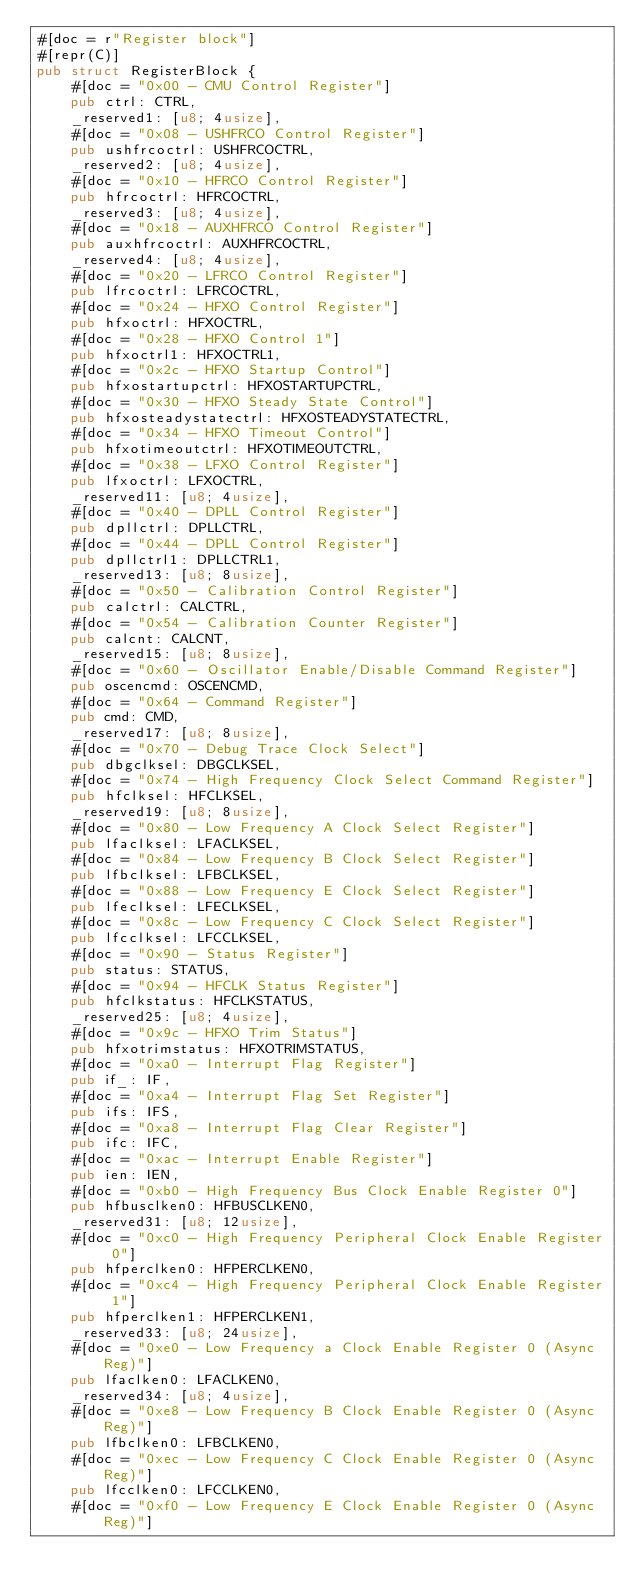<code> <loc_0><loc_0><loc_500><loc_500><_Rust_>#[doc = r"Register block"]
#[repr(C)]
pub struct RegisterBlock {
    #[doc = "0x00 - CMU Control Register"]
    pub ctrl: CTRL,
    _reserved1: [u8; 4usize],
    #[doc = "0x08 - USHFRCO Control Register"]
    pub ushfrcoctrl: USHFRCOCTRL,
    _reserved2: [u8; 4usize],
    #[doc = "0x10 - HFRCO Control Register"]
    pub hfrcoctrl: HFRCOCTRL,
    _reserved3: [u8; 4usize],
    #[doc = "0x18 - AUXHFRCO Control Register"]
    pub auxhfrcoctrl: AUXHFRCOCTRL,
    _reserved4: [u8; 4usize],
    #[doc = "0x20 - LFRCO Control Register"]
    pub lfrcoctrl: LFRCOCTRL,
    #[doc = "0x24 - HFXO Control Register"]
    pub hfxoctrl: HFXOCTRL,
    #[doc = "0x28 - HFXO Control 1"]
    pub hfxoctrl1: HFXOCTRL1,
    #[doc = "0x2c - HFXO Startup Control"]
    pub hfxostartupctrl: HFXOSTARTUPCTRL,
    #[doc = "0x30 - HFXO Steady State Control"]
    pub hfxosteadystatectrl: HFXOSTEADYSTATECTRL,
    #[doc = "0x34 - HFXO Timeout Control"]
    pub hfxotimeoutctrl: HFXOTIMEOUTCTRL,
    #[doc = "0x38 - LFXO Control Register"]
    pub lfxoctrl: LFXOCTRL,
    _reserved11: [u8; 4usize],
    #[doc = "0x40 - DPLL Control Register"]
    pub dpllctrl: DPLLCTRL,
    #[doc = "0x44 - DPLL Control Register"]
    pub dpllctrl1: DPLLCTRL1,
    _reserved13: [u8; 8usize],
    #[doc = "0x50 - Calibration Control Register"]
    pub calctrl: CALCTRL,
    #[doc = "0x54 - Calibration Counter Register"]
    pub calcnt: CALCNT,
    _reserved15: [u8; 8usize],
    #[doc = "0x60 - Oscillator Enable/Disable Command Register"]
    pub oscencmd: OSCENCMD,
    #[doc = "0x64 - Command Register"]
    pub cmd: CMD,
    _reserved17: [u8; 8usize],
    #[doc = "0x70 - Debug Trace Clock Select"]
    pub dbgclksel: DBGCLKSEL,
    #[doc = "0x74 - High Frequency Clock Select Command Register"]
    pub hfclksel: HFCLKSEL,
    _reserved19: [u8; 8usize],
    #[doc = "0x80 - Low Frequency A Clock Select Register"]
    pub lfaclksel: LFACLKSEL,
    #[doc = "0x84 - Low Frequency B Clock Select Register"]
    pub lfbclksel: LFBCLKSEL,
    #[doc = "0x88 - Low Frequency E Clock Select Register"]
    pub lfeclksel: LFECLKSEL,
    #[doc = "0x8c - Low Frequency C Clock Select Register"]
    pub lfcclksel: LFCCLKSEL,
    #[doc = "0x90 - Status Register"]
    pub status: STATUS,
    #[doc = "0x94 - HFCLK Status Register"]
    pub hfclkstatus: HFCLKSTATUS,
    _reserved25: [u8; 4usize],
    #[doc = "0x9c - HFXO Trim Status"]
    pub hfxotrimstatus: HFXOTRIMSTATUS,
    #[doc = "0xa0 - Interrupt Flag Register"]
    pub if_: IF,
    #[doc = "0xa4 - Interrupt Flag Set Register"]
    pub ifs: IFS,
    #[doc = "0xa8 - Interrupt Flag Clear Register"]
    pub ifc: IFC,
    #[doc = "0xac - Interrupt Enable Register"]
    pub ien: IEN,
    #[doc = "0xb0 - High Frequency Bus Clock Enable Register 0"]
    pub hfbusclken0: HFBUSCLKEN0,
    _reserved31: [u8; 12usize],
    #[doc = "0xc0 - High Frequency Peripheral Clock Enable Register 0"]
    pub hfperclken0: HFPERCLKEN0,
    #[doc = "0xc4 - High Frequency Peripheral Clock Enable Register 1"]
    pub hfperclken1: HFPERCLKEN1,
    _reserved33: [u8; 24usize],
    #[doc = "0xe0 - Low Frequency a Clock Enable Register 0 (Async Reg)"]
    pub lfaclken0: LFACLKEN0,
    _reserved34: [u8; 4usize],
    #[doc = "0xe8 - Low Frequency B Clock Enable Register 0 (Async Reg)"]
    pub lfbclken0: LFBCLKEN0,
    #[doc = "0xec - Low Frequency C Clock Enable Register 0 (Async Reg)"]
    pub lfcclken0: LFCCLKEN0,
    #[doc = "0xf0 - Low Frequency E Clock Enable Register 0 (Async Reg)"]</code> 